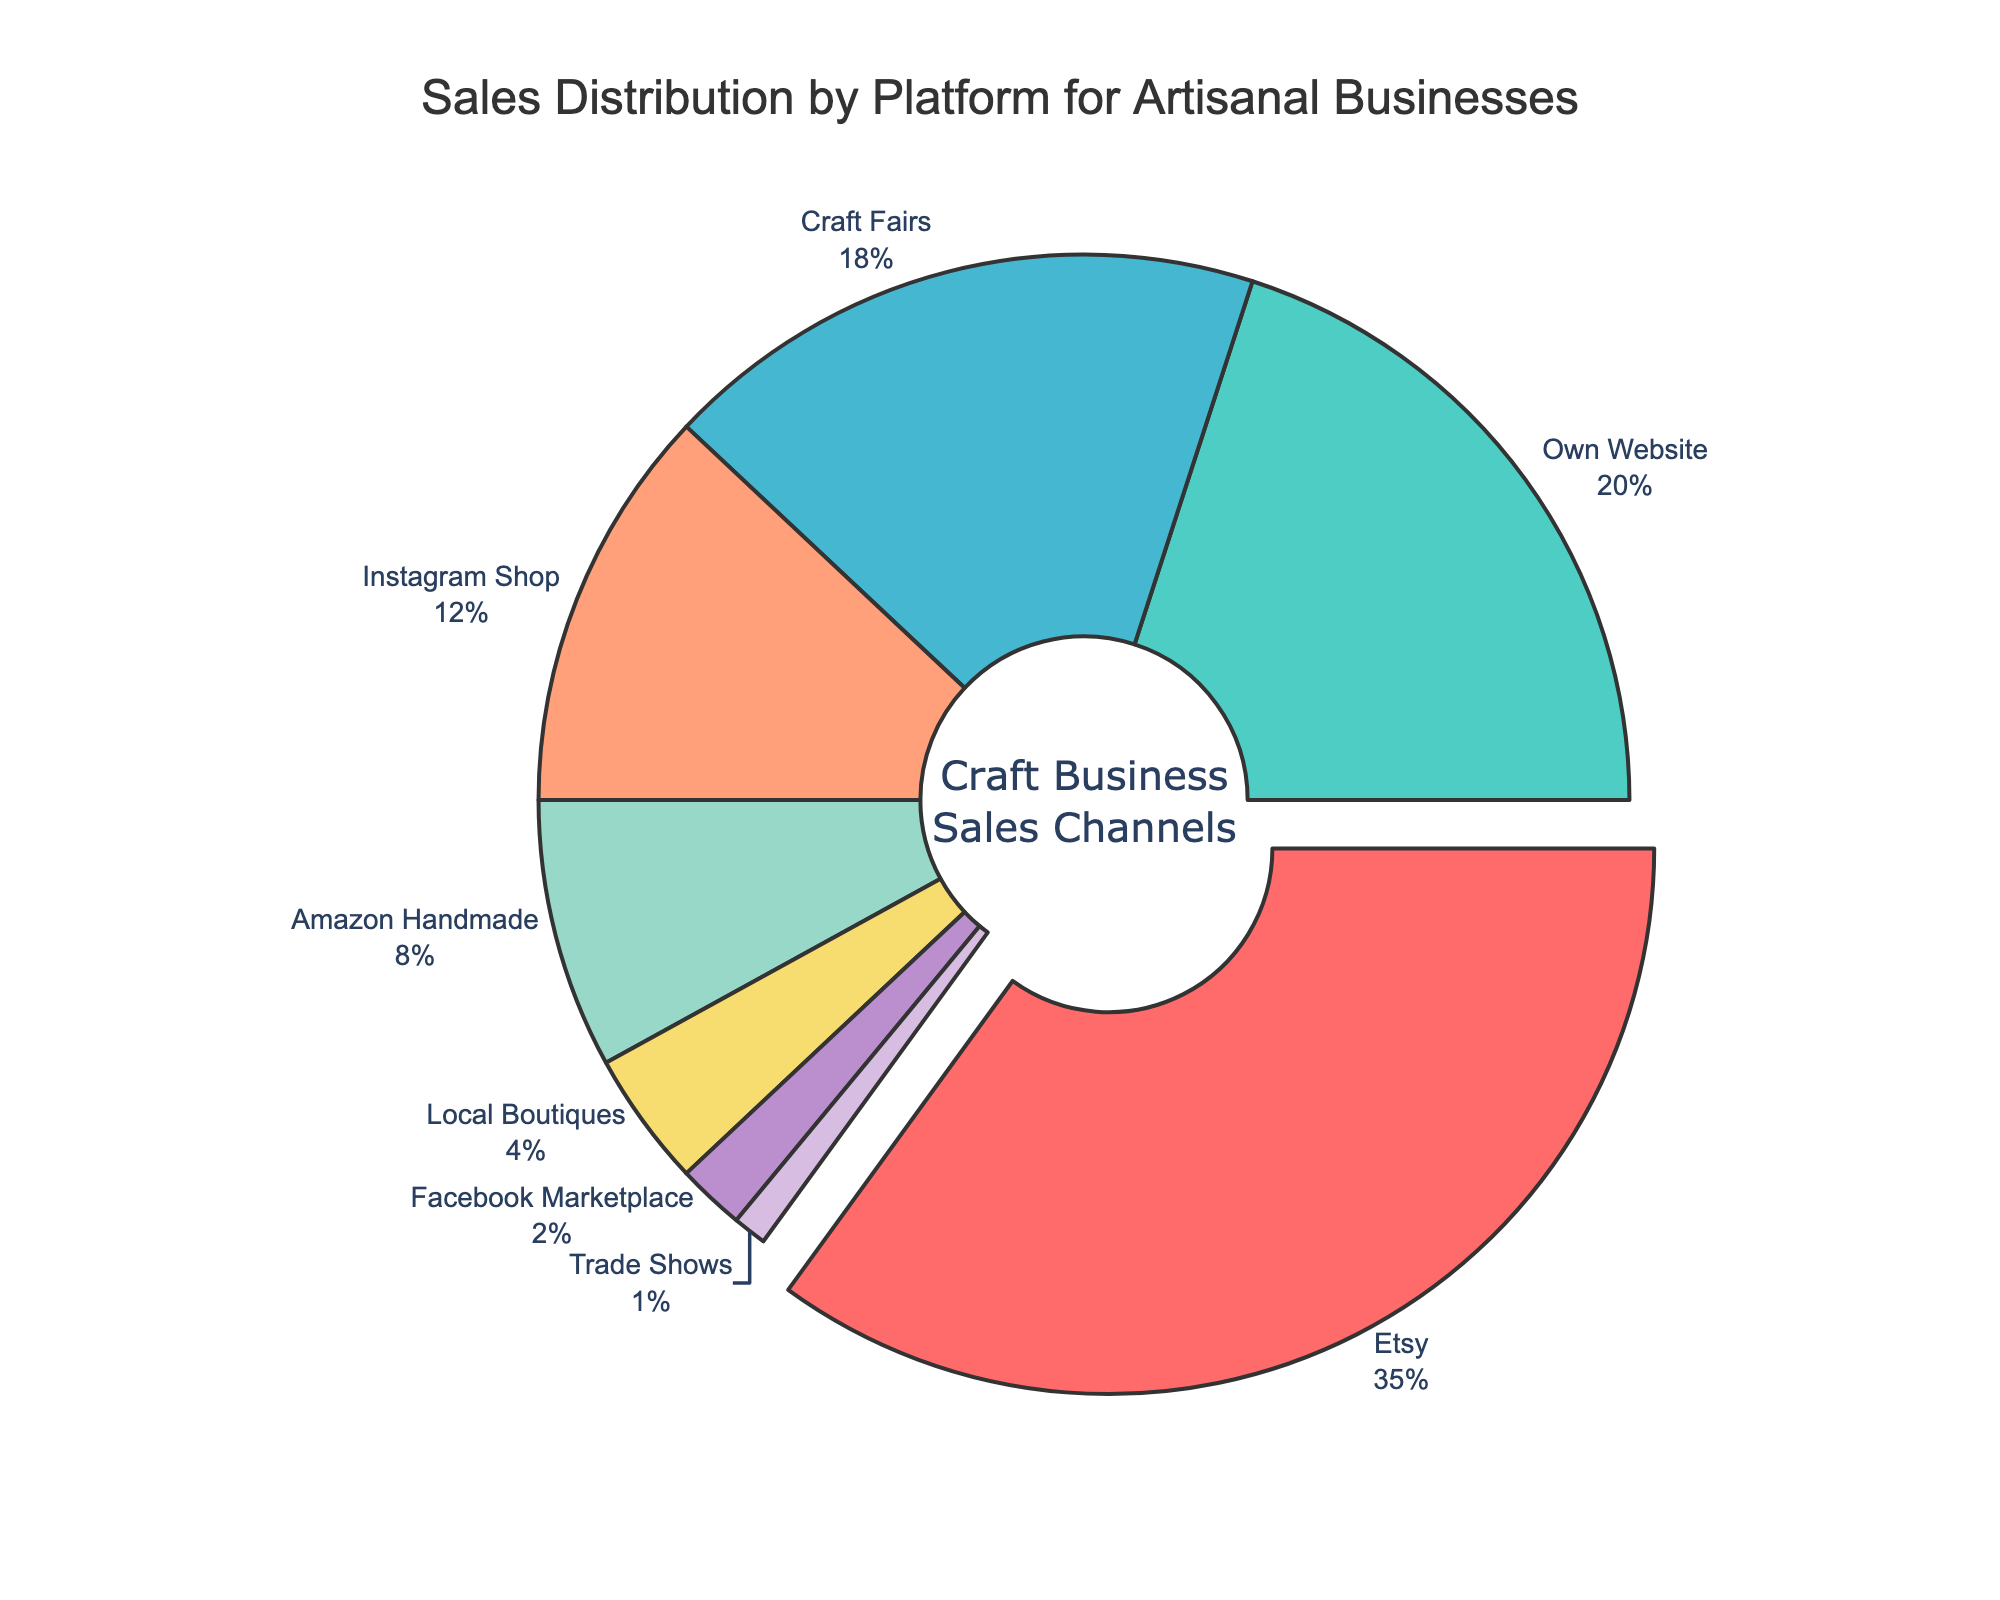What percentage of sales are made through Instagram Shop and Local Boutiques combined? Add the percentages of Instagram Shop (12%) and Local Boutiques (4%). So, 12 + 4 = 16.
Answer: 16 Which platform generates the highest percentage of sales? The platform with the largest slice of the pie and a slight pull-out is Etsy with 35% of sales.
Answer: Etsy How does the percentage of sales through Amazon Handmade compare to Craft Fairs? Compare the percentages: Amazon Handmade has 8%, and Craft Fairs have 18%.
Answer: Craft Fairs have a higher percentage What percentage of sales come from platforms other than Etsy? Subtract Etsy's percentage (35%) from 100%: 100 - 35 = 65.
Answer: 65 What is the percentage difference between the platform with the highest sales and the platform with the lowest sales? Subtract the percentage of Trade Shows (1%) from Etsy (35%): 35 - 1 = 34.
Answer: 34 Which platform has the smallest share in the sales distribution? Look for the smallest slice of the pie chart. Trade Shows have 1%.
Answer: Trade Shows What is the combined percentage of sales through Own Website, Facebook Marketplace, and Craft Fairs? Add the percentages: Own Website (20%) + Facebook Marketplace (2%) + Craft Fairs (18%) which equals 20 + 2 + 18 = 40.
Answer: 40 If you were to remove sales data from Etsy, what would be the average sales percentage for the remaining platforms? First remove Etsy's percentage. Then, find the average of the remaining percentages: (20 + 18 + 12 + 8 + 4 + 2 + 1) / 7 = 65 / 7 ≈ 9.29.
Answer: 9.29 Which platform or platforms take up more than 10% of the total sales? Identify slices over 10%: Etsy (35%), Own Website (20%), Craft Fairs (18%), and Instagram Shop (12%).
Answer: Etsy, Own Website, Craft Fairs, Instagram Shop 